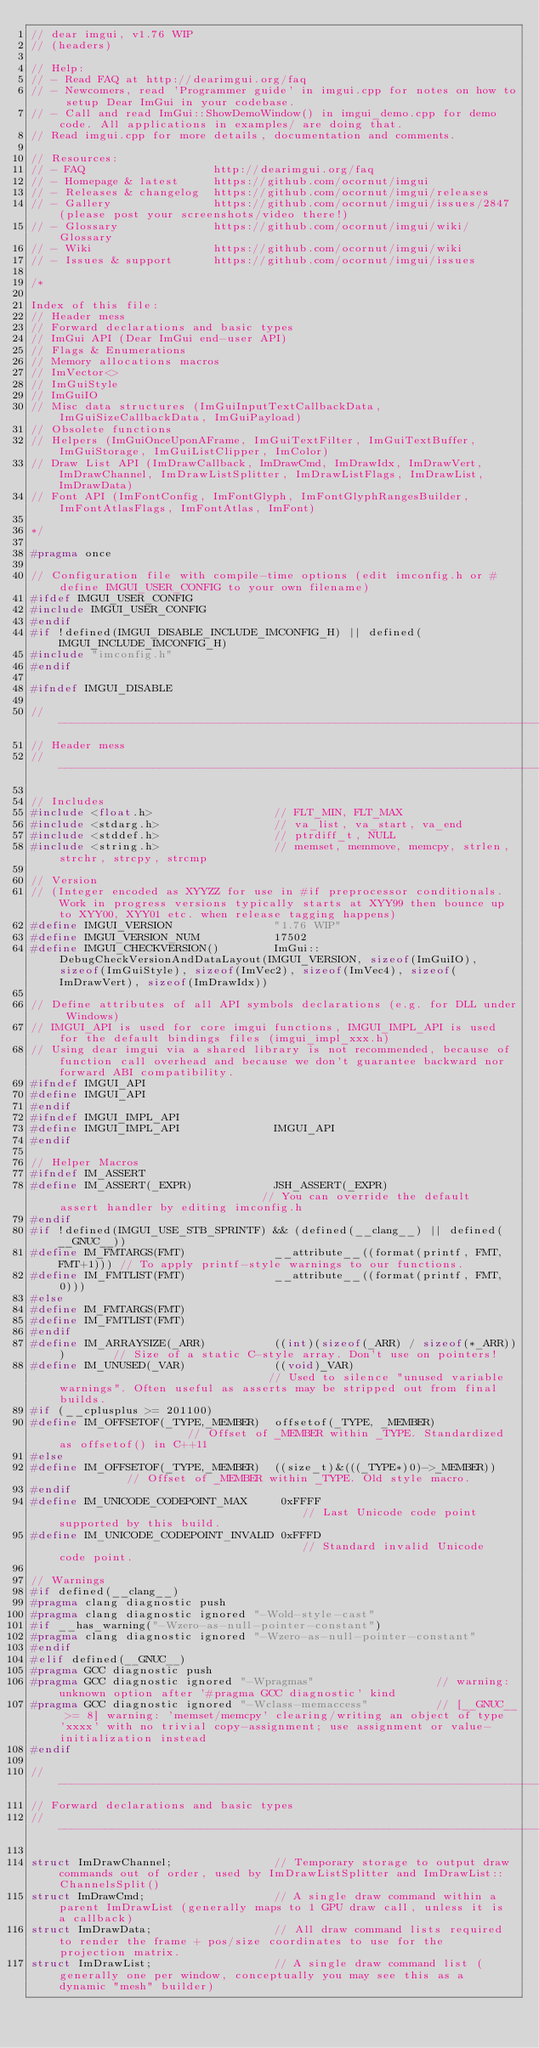<code> <loc_0><loc_0><loc_500><loc_500><_C_>// dear imgui, v1.76 WIP
// (headers)

// Help:
// - Read FAQ at http://dearimgui.org/faq
// - Newcomers, read 'Programmer guide' in imgui.cpp for notes on how to setup Dear ImGui in your codebase.
// - Call and read ImGui::ShowDemoWindow() in imgui_demo.cpp for demo code. All applications in examples/ are doing that.
// Read imgui.cpp for more details, documentation and comments.

// Resources:
// - FAQ                   http://dearimgui.org/faq
// - Homepage & latest     https://github.com/ocornut/imgui
// - Releases & changelog  https://github.com/ocornut/imgui/releases
// - Gallery               https://github.com/ocornut/imgui/issues/2847 (please post your screenshots/video there!)
// - Glossary              https://github.com/ocornut/imgui/wiki/Glossary
// - Wiki                  https://github.com/ocornut/imgui/wiki
// - Issues & support      https://github.com/ocornut/imgui/issues

/*

Index of this file:
// Header mess
// Forward declarations and basic types
// ImGui API (Dear ImGui end-user API)
// Flags & Enumerations
// Memory allocations macros
// ImVector<>
// ImGuiStyle
// ImGuiIO
// Misc data structures (ImGuiInputTextCallbackData, ImGuiSizeCallbackData, ImGuiPayload)
// Obsolete functions
// Helpers (ImGuiOnceUponAFrame, ImGuiTextFilter, ImGuiTextBuffer, ImGuiStorage, ImGuiListClipper, ImColor)
// Draw List API (ImDrawCallback, ImDrawCmd, ImDrawIdx, ImDrawVert, ImDrawChannel, ImDrawListSplitter, ImDrawListFlags, ImDrawList, ImDrawData)
// Font API (ImFontConfig, ImFontGlyph, ImFontGlyphRangesBuilder, ImFontAtlasFlags, ImFontAtlas, ImFont)

*/

#pragma once

// Configuration file with compile-time options (edit imconfig.h or #define IMGUI_USER_CONFIG to your own filename)
#ifdef IMGUI_USER_CONFIG
#include IMGUI_USER_CONFIG
#endif
#if !defined(IMGUI_DISABLE_INCLUDE_IMCONFIG_H) || defined(IMGUI_INCLUDE_IMCONFIG_H)
#include "imconfig.h"
#endif

#ifndef IMGUI_DISABLE

//-----------------------------------------------------------------------------
// Header mess
//-----------------------------------------------------------------------------

// Includes
#include <float.h>                  // FLT_MIN, FLT_MAX
#include <stdarg.h>                 // va_list, va_start, va_end
#include <stddef.h>                 // ptrdiff_t, NULL
#include <string.h>                 // memset, memmove, memcpy, strlen, strchr, strcpy, strcmp

// Version
// (Integer encoded as XYYZZ for use in #if preprocessor conditionals. Work in progress versions typically starts at XYY99 then bounce up to XYY00, XYY01 etc. when release tagging happens)
#define IMGUI_VERSION               "1.76 WIP"
#define IMGUI_VERSION_NUM           17502
#define IMGUI_CHECKVERSION()        ImGui::DebugCheckVersionAndDataLayout(IMGUI_VERSION, sizeof(ImGuiIO), sizeof(ImGuiStyle), sizeof(ImVec2), sizeof(ImVec4), sizeof(ImDrawVert), sizeof(ImDrawIdx))

// Define attributes of all API symbols declarations (e.g. for DLL under Windows)
// IMGUI_API is used for core imgui functions, IMGUI_IMPL_API is used for the default bindings files (imgui_impl_xxx.h)
// Using dear imgui via a shared library is not recommended, because of function call overhead and because we don't guarantee backward nor forward ABI compatibility.
#ifndef IMGUI_API
#define IMGUI_API
#endif
#ifndef IMGUI_IMPL_API
#define IMGUI_IMPL_API              IMGUI_API
#endif

// Helper Macros
#ifndef IM_ASSERT
#define IM_ASSERT(_EXPR)            JSH_ASSERT(_EXPR)                               // You can override the default assert handler by editing imconfig.h
#endif
#if !defined(IMGUI_USE_STB_SPRINTF) && (defined(__clang__) || defined(__GNUC__))
#define IM_FMTARGS(FMT)             __attribute__((format(printf, FMT, FMT+1))) // To apply printf-style warnings to our functions.
#define IM_FMTLIST(FMT)             __attribute__((format(printf, FMT, 0)))
#else
#define IM_FMTARGS(FMT)
#define IM_FMTLIST(FMT)
#endif
#define IM_ARRAYSIZE(_ARR)          ((int)(sizeof(_ARR) / sizeof(*_ARR)))       // Size of a static C-style array. Don't use on pointers!
#define IM_UNUSED(_VAR)             ((void)_VAR)                                // Used to silence "unused variable warnings". Often useful as asserts may be stripped out from final builds.
#if (__cplusplus >= 201100)
#define IM_OFFSETOF(_TYPE,_MEMBER)  offsetof(_TYPE, _MEMBER)                    // Offset of _MEMBER within _TYPE. Standardized as offsetof() in C++11
#else
#define IM_OFFSETOF(_TYPE,_MEMBER)  ((size_t)&(((_TYPE*)0)->_MEMBER))           // Offset of _MEMBER within _TYPE. Old style macro.
#endif
#define IM_UNICODE_CODEPOINT_MAX     0xFFFF                                     // Last Unicode code point supported by this build.
#define IM_UNICODE_CODEPOINT_INVALID 0xFFFD                                     // Standard invalid Unicode code point.

// Warnings
#if defined(__clang__)
#pragma clang diagnostic push
#pragma clang diagnostic ignored "-Wold-style-cast"
#if __has_warning("-Wzero-as-null-pointer-constant")
#pragma clang diagnostic ignored "-Wzero-as-null-pointer-constant"
#endif
#elif defined(__GNUC__)
#pragma GCC diagnostic push
#pragma GCC diagnostic ignored "-Wpragmas"                  // warning: unknown option after '#pragma GCC diagnostic' kind
#pragma GCC diagnostic ignored "-Wclass-memaccess"          // [__GNUC__ >= 8] warning: 'memset/memcpy' clearing/writing an object of type 'xxxx' with no trivial copy-assignment; use assignment or value-initialization instead
#endif

//-----------------------------------------------------------------------------
// Forward declarations and basic types
//-----------------------------------------------------------------------------

struct ImDrawChannel;               // Temporary storage to output draw commands out of order, used by ImDrawListSplitter and ImDrawList::ChannelsSplit()
struct ImDrawCmd;                   // A single draw command within a parent ImDrawList (generally maps to 1 GPU draw call, unless it is a callback)
struct ImDrawData;                  // All draw command lists required to render the frame + pos/size coordinates to use for the projection matrix.
struct ImDrawList;                  // A single draw command list (generally one per window, conceptually you may see this as a dynamic "mesh" builder)</code> 